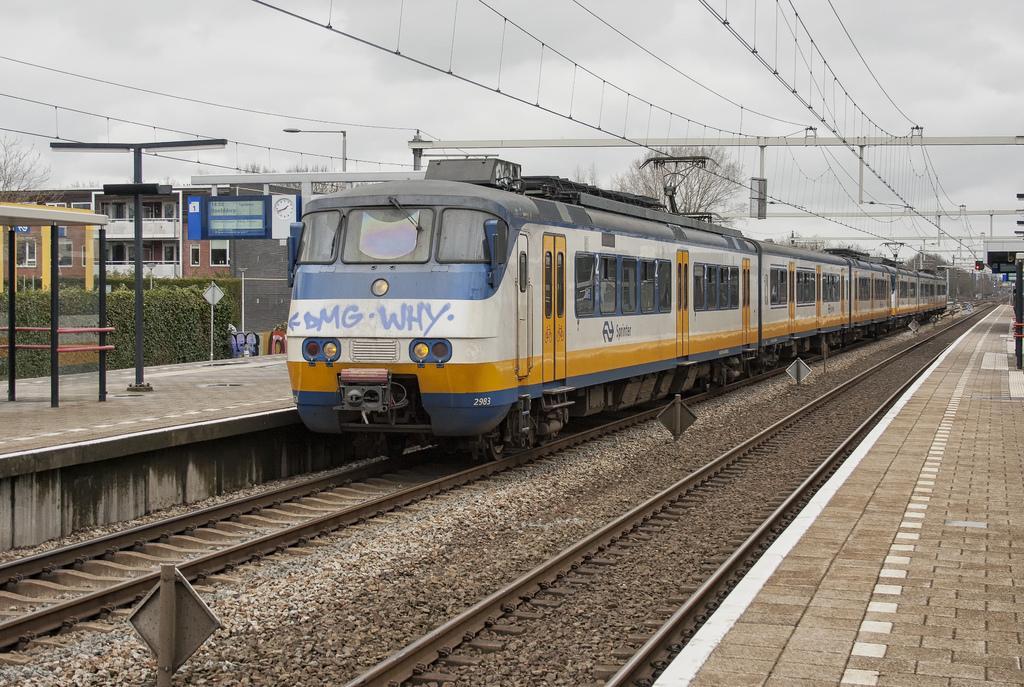Please provide a concise description of this image. In this image we can see a train on the railway track. Here we can see the boards, wires, platforms, shrubs, houses, clock, light poles, dry trees and the cloudy sky in the background. 